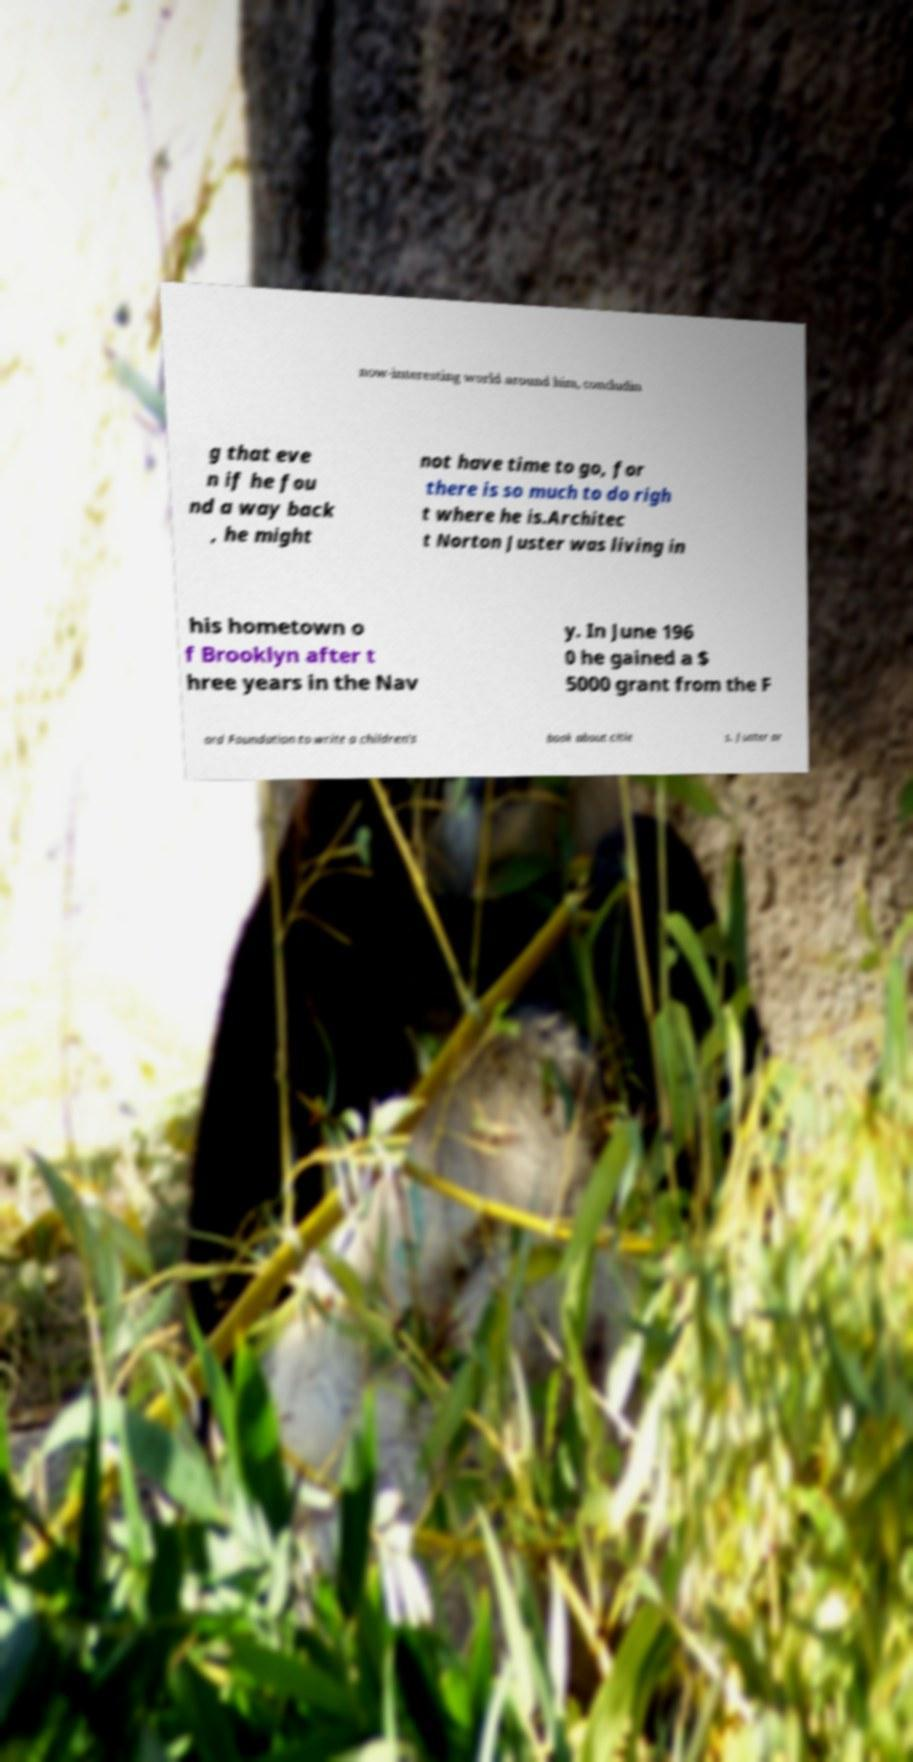I need the written content from this picture converted into text. Can you do that? now-interesting world around him, concludin g that eve n if he fou nd a way back , he might not have time to go, for there is so much to do righ t where he is.Architec t Norton Juster was living in his hometown o f Brooklyn after t hree years in the Nav y. In June 196 0 he gained a $ 5000 grant from the F ord Foundation to write a children's book about citie s. Juster ar 